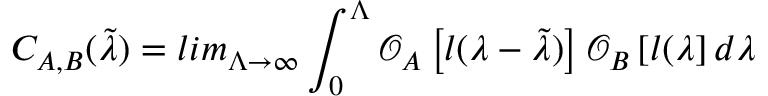Convert formula to latex. <formula><loc_0><loc_0><loc_500><loc_500>C _ { A , B } ( \tilde { \lambda } ) = l i m _ { \Lambda \to \infty } \int _ { 0 } ^ { \Lambda } \mathcal { O } _ { A } \left [ l ( \lambda - \tilde { \lambda } ) \right ] \mathcal { O } _ { B } \left [ l ( \lambda \right ] d \lambda</formula> 